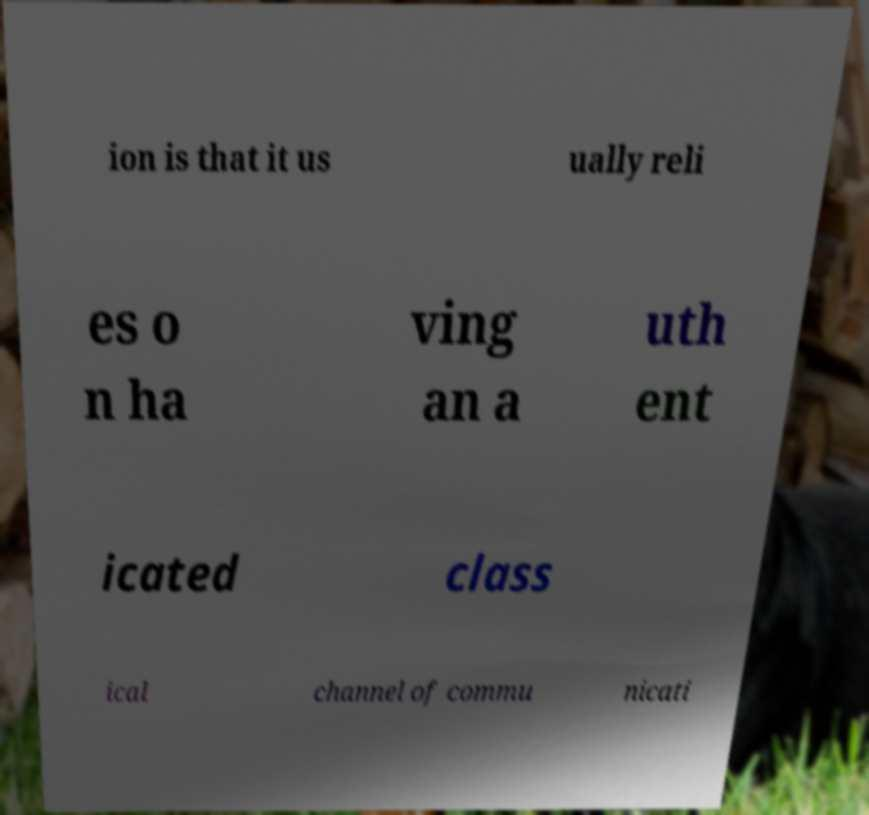Please identify and transcribe the text found in this image. ion is that it us ually reli es o n ha ving an a uth ent icated class ical channel of commu nicati 